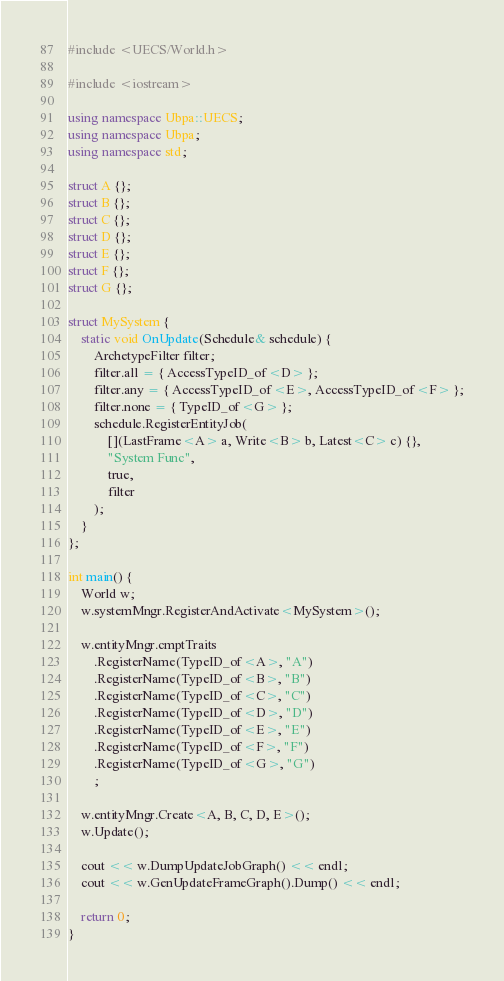<code> <loc_0><loc_0><loc_500><loc_500><_C++_>#include <UECS/World.h>

#include <iostream>

using namespace Ubpa::UECS;
using namespace Ubpa;
using namespace std;

struct A {};
struct B {};
struct C {};
struct D {};
struct E {};
struct F {};
struct G {};

struct MySystem {
	static void OnUpdate(Schedule& schedule) {
		ArchetypeFilter filter;
		filter.all = { AccessTypeID_of<D> };
		filter.any = { AccessTypeID_of<E>, AccessTypeID_of<F> };
		filter.none = { TypeID_of<G> };
		schedule.RegisterEntityJob(
			[](LastFrame<A> a, Write<B> b, Latest<C> c) {},
			"System Func",
			true,
			filter
		);
	}
};

int main() {
	World w;
	w.systemMngr.RegisterAndActivate<MySystem>();

	w.entityMngr.cmptTraits
		.RegisterName(TypeID_of<A>, "A")
		.RegisterName(TypeID_of<B>, "B")
		.RegisterName(TypeID_of<C>, "C")
		.RegisterName(TypeID_of<D>, "D")
		.RegisterName(TypeID_of<E>, "E")
		.RegisterName(TypeID_of<F>, "F")
		.RegisterName(TypeID_of<G>, "G")
		;

	w.entityMngr.Create<A, B, C, D, E>();
	w.Update();

	cout << w.DumpUpdateJobGraph() << endl;
	cout << w.GenUpdateFrameGraph().Dump() << endl;

	return 0;
}
</code> 